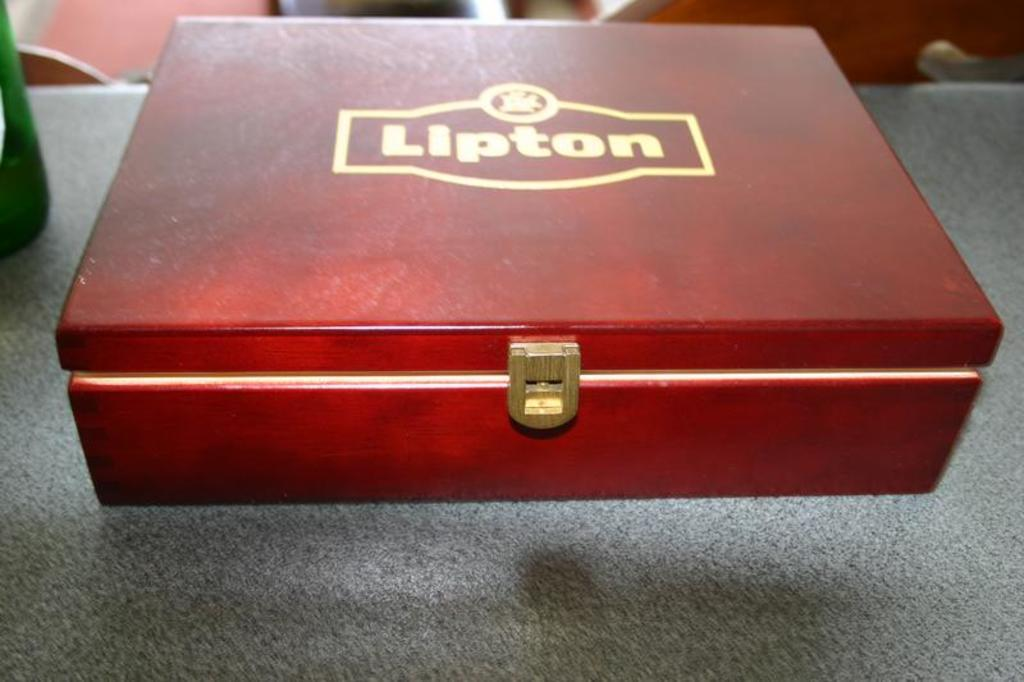Provide a one-sentence caption for the provided image. lipton tea wooden box sits on the counter. 